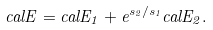<formula> <loc_0><loc_0><loc_500><loc_500>c a l E = c a l E _ { 1 } + e ^ { s _ { 2 } / s _ { 1 } } c a l E _ { 2 } .</formula> 